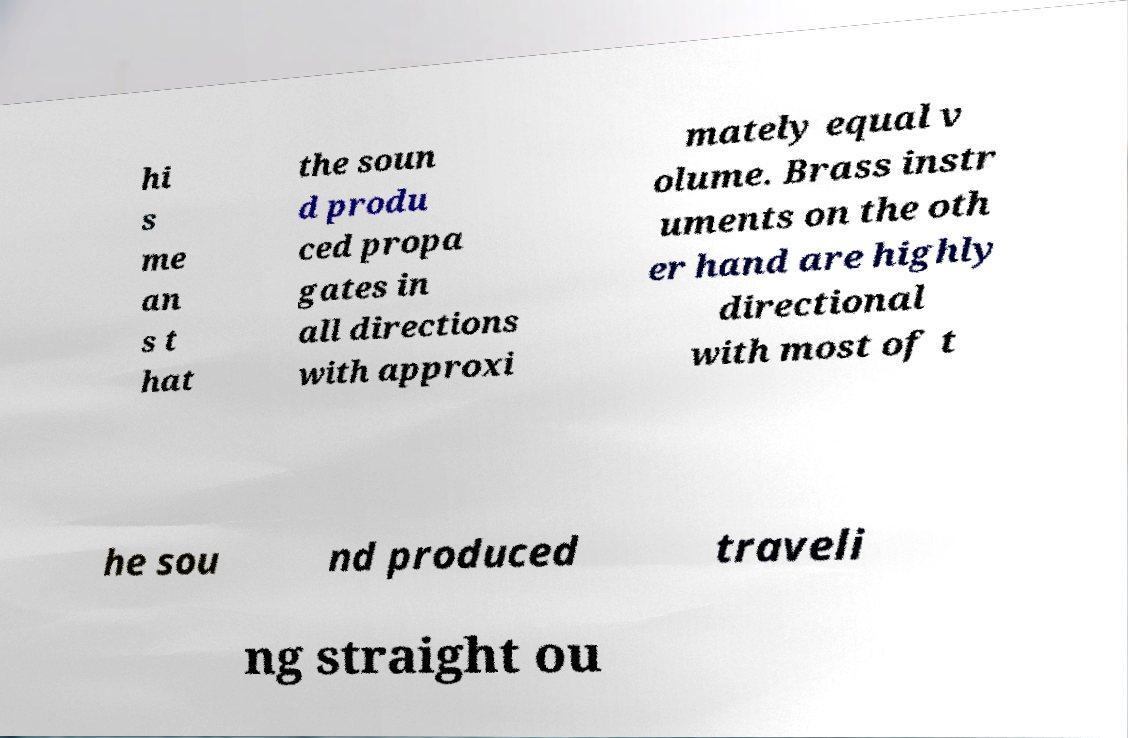Please identify and transcribe the text found in this image. hi s me an s t hat the soun d produ ced propa gates in all directions with approxi mately equal v olume. Brass instr uments on the oth er hand are highly directional with most of t he sou nd produced traveli ng straight ou 